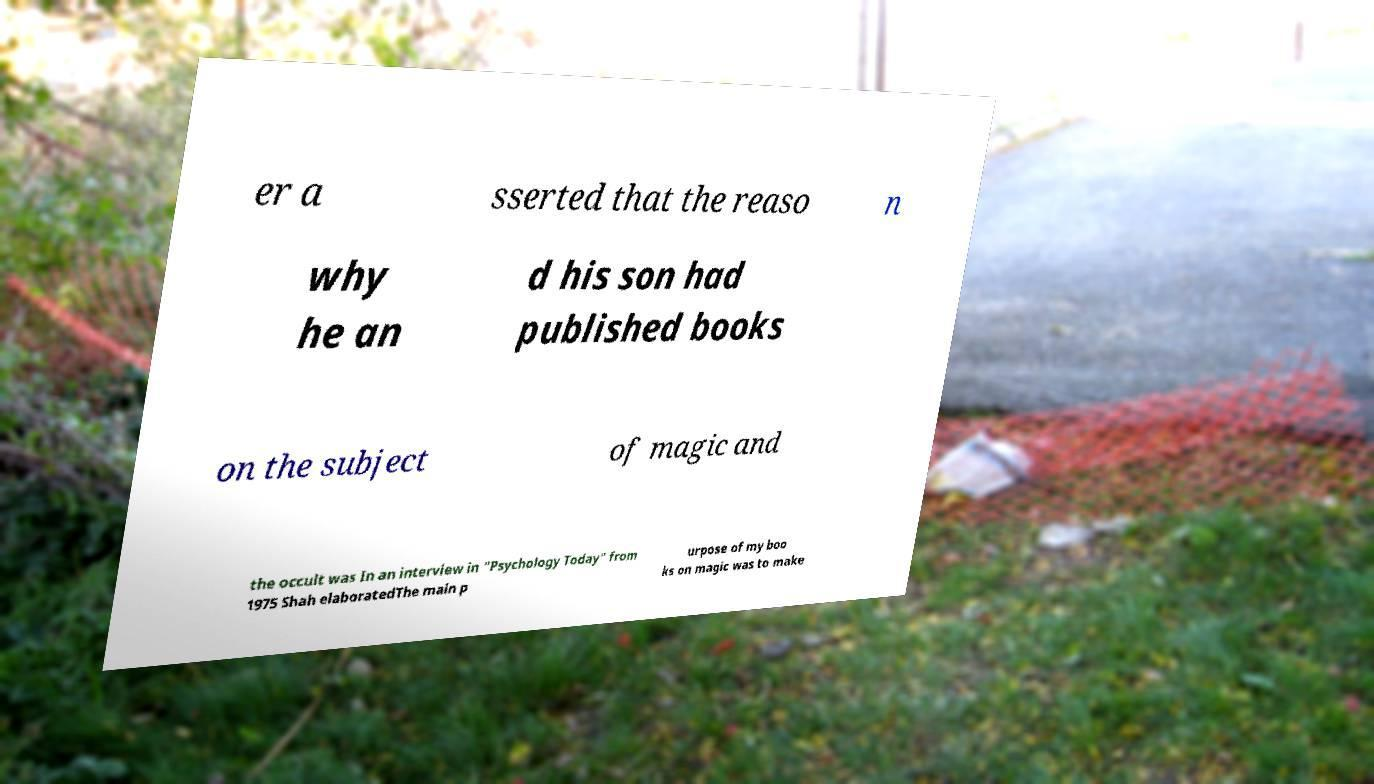For documentation purposes, I need the text within this image transcribed. Could you provide that? er a sserted that the reaso n why he an d his son had published books on the subject of magic and the occult was In an interview in "Psychology Today" from 1975 Shah elaboratedThe main p urpose of my boo ks on magic was to make 